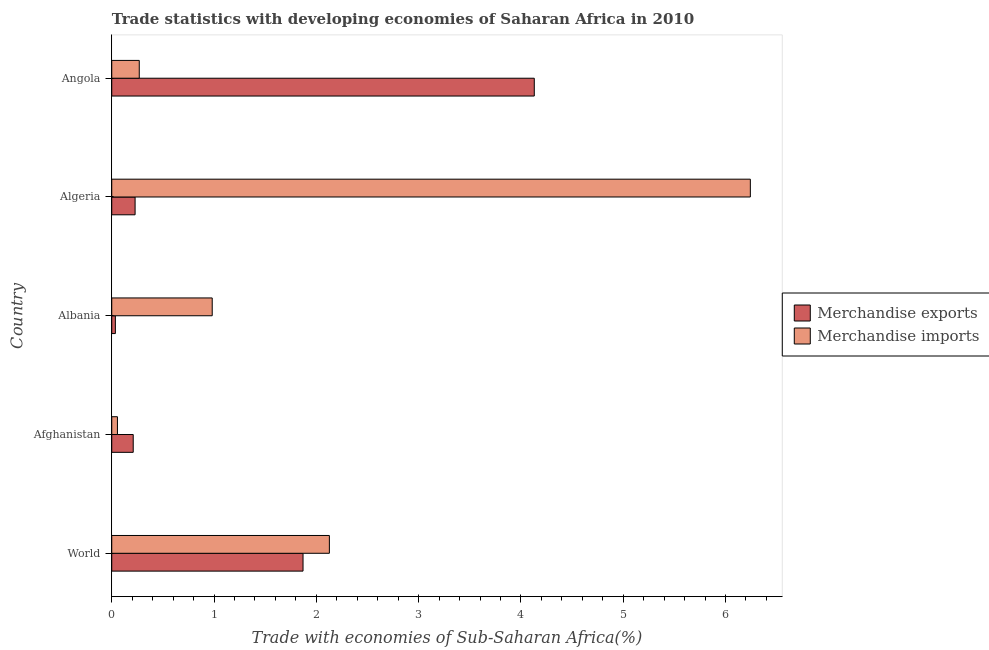How many different coloured bars are there?
Your response must be concise. 2. How many groups of bars are there?
Offer a very short reply. 5. Are the number of bars per tick equal to the number of legend labels?
Ensure brevity in your answer.  Yes. How many bars are there on the 1st tick from the bottom?
Your answer should be very brief. 2. What is the label of the 2nd group of bars from the top?
Make the answer very short. Algeria. In how many cases, is the number of bars for a given country not equal to the number of legend labels?
Your answer should be very brief. 0. What is the merchandise exports in Algeria?
Give a very brief answer. 0.23. Across all countries, what is the maximum merchandise imports?
Keep it short and to the point. 6.24. Across all countries, what is the minimum merchandise imports?
Give a very brief answer. 0.06. In which country was the merchandise exports maximum?
Your response must be concise. Angola. In which country was the merchandise exports minimum?
Give a very brief answer. Albania. What is the total merchandise imports in the graph?
Provide a succinct answer. 9.68. What is the difference between the merchandise imports in Afghanistan and that in Albania?
Provide a short and direct response. -0.93. What is the difference between the merchandise imports in World and the merchandise exports in Albania?
Keep it short and to the point. 2.09. What is the average merchandise exports per country?
Offer a very short reply. 1.29. What is the difference between the merchandise imports and merchandise exports in Albania?
Your response must be concise. 0.95. In how many countries, is the merchandise imports greater than 2.8 %?
Your response must be concise. 1. What is the ratio of the merchandise imports in Algeria to that in World?
Provide a succinct answer. 2.93. What is the difference between the highest and the second highest merchandise imports?
Keep it short and to the point. 4.12. Is the sum of the merchandise exports in Albania and Angola greater than the maximum merchandise imports across all countries?
Your answer should be very brief. No. What is the difference between two consecutive major ticks on the X-axis?
Make the answer very short. 1. Are the values on the major ticks of X-axis written in scientific E-notation?
Make the answer very short. No. Where does the legend appear in the graph?
Provide a succinct answer. Center right. How many legend labels are there?
Make the answer very short. 2. How are the legend labels stacked?
Your answer should be very brief. Vertical. What is the title of the graph?
Ensure brevity in your answer.  Trade statistics with developing economies of Saharan Africa in 2010. What is the label or title of the X-axis?
Your answer should be compact. Trade with economies of Sub-Saharan Africa(%). What is the Trade with economies of Sub-Saharan Africa(%) of Merchandise exports in World?
Your answer should be compact. 1.87. What is the Trade with economies of Sub-Saharan Africa(%) of Merchandise imports in World?
Ensure brevity in your answer.  2.13. What is the Trade with economies of Sub-Saharan Africa(%) in Merchandise exports in Afghanistan?
Give a very brief answer. 0.21. What is the Trade with economies of Sub-Saharan Africa(%) in Merchandise imports in Afghanistan?
Your answer should be very brief. 0.06. What is the Trade with economies of Sub-Saharan Africa(%) of Merchandise exports in Albania?
Offer a terse response. 0.04. What is the Trade with economies of Sub-Saharan Africa(%) of Merchandise imports in Albania?
Give a very brief answer. 0.98. What is the Trade with economies of Sub-Saharan Africa(%) in Merchandise exports in Algeria?
Provide a succinct answer. 0.23. What is the Trade with economies of Sub-Saharan Africa(%) of Merchandise imports in Algeria?
Your answer should be very brief. 6.24. What is the Trade with economies of Sub-Saharan Africa(%) in Merchandise exports in Angola?
Your response must be concise. 4.13. What is the Trade with economies of Sub-Saharan Africa(%) in Merchandise imports in Angola?
Ensure brevity in your answer.  0.27. Across all countries, what is the maximum Trade with economies of Sub-Saharan Africa(%) of Merchandise exports?
Provide a succinct answer. 4.13. Across all countries, what is the maximum Trade with economies of Sub-Saharan Africa(%) of Merchandise imports?
Your answer should be compact. 6.24. Across all countries, what is the minimum Trade with economies of Sub-Saharan Africa(%) in Merchandise exports?
Make the answer very short. 0.04. Across all countries, what is the minimum Trade with economies of Sub-Saharan Africa(%) in Merchandise imports?
Offer a very short reply. 0.06. What is the total Trade with economies of Sub-Saharan Africa(%) of Merchandise exports in the graph?
Your answer should be compact. 6.47. What is the total Trade with economies of Sub-Saharan Africa(%) of Merchandise imports in the graph?
Ensure brevity in your answer.  9.68. What is the difference between the Trade with economies of Sub-Saharan Africa(%) in Merchandise exports in World and that in Afghanistan?
Ensure brevity in your answer.  1.66. What is the difference between the Trade with economies of Sub-Saharan Africa(%) in Merchandise imports in World and that in Afghanistan?
Make the answer very short. 2.07. What is the difference between the Trade with economies of Sub-Saharan Africa(%) in Merchandise exports in World and that in Albania?
Provide a succinct answer. 1.83. What is the difference between the Trade with economies of Sub-Saharan Africa(%) of Merchandise imports in World and that in Albania?
Offer a terse response. 1.15. What is the difference between the Trade with economies of Sub-Saharan Africa(%) of Merchandise exports in World and that in Algeria?
Ensure brevity in your answer.  1.64. What is the difference between the Trade with economies of Sub-Saharan Africa(%) of Merchandise imports in World and that in Algeria?
Make the answer very short. -4.12. What is the difference between the Trade with economies of Sub-Saharan Africa(%) of Merchandise exports in World and that in Angola?
Make the answer very short. -2.26. What is the difference between the Trade with economies of Sub-Saharan Africa(%) in Merchandise imports in World and that in Angola?
Your answer should be compact. 1.86. What is the difference between the Trade with economies of Sub-Saharan Africa(%) of Merchandise exports in Afghanistan and that in Albania?
Your answer should be compact. 0.17. What is the difference between the Trade with economies of Sub-Saharan Africa(%) of Merchandise imports in Afghanistan and that in Albania?
Keep it short and to the point. -0.93. What is the difference between the Trade with economies of Sub-Saharan Africa(%) in Merchandise exports in Afghanistan and that in Algeria?
Ensure brevity in your answer.  -0.02. What is the difference between the Trade with economies of Sub-Saharan Africa(%) in Merchandise imports in Afghanistan and that in Algeria?
Ensure brevity in your answer.  -6.19. What is the difference between the Trade with economies of Sub-Saharan Africa(%) of Merchandise exports in Afghanistan and that in Angola?
Your response must be concise. -3.92. What is the difference between the Trade with economies of Sub-Saharan Africa(%) in Merchandise imports in Afghanistan and that in Angola?
Your answer should be very brief. -0.21. What is the difference between the Trade with economies of Sub-Saharan Africa(%) in Merchandise exports in Albania and that in Algeria?
Provide a short and direct response. -0.19. What is the difference between the Trade with economies of Sub-Saharan Africa(%) in Merchandise imports in Albania and that in Algeria?
Ensure brevity in your answer.  -5.26. What is the difference between the Trade with economies of Sub-Saharan Africa(%) in Merchandise exports in Albania and that in Angola?
Offer a very short reply. -4.1. What is the difference between the Trade with economies of Sub-Saharan Africa(%) in Merchandise imports in Albania and that in Angola?
Provide a short and direct response. 0.71. What is the difference between the Trade with economies of Sub-Saharan Africa(%) in Merchandise exports in Algeria and that in Angola?
Make the answer very short. -3.9. What is the difference between the Trade with economies of Sub-Saharan Africa(%) in Merchandise imports in Algeria and that in Angola?
Your response must be concise. 5.97. What is the difference between the Trade with economies of Sub-Saharan Africa(%) of Merchandise exports in World and the Trade with economies of Sub-Saharan Africa(%) of Merchandise imports in Afghanistan?
Your answer should be very brief. 1.81. What is the difference between the Trade with economies of Sub-Saharan Africa(%) of Merchandise exports in World and the Trade with economies of Sub-Saharan Africa(%) of Merchandise imports in Albania?
Your answer should be very brief. 0.89. What is the difference between the Trade with economies of Sub-Saharan Africa(%) in Merchandise exports in World and the Trade with economies of Sub-Saharan Africa(%) in Merchandise imports in Algeria?
Your answer should be compact. -4.37. What is the difference between the Trade with economies of Sub-Saharan Africa(%) of Merchandise exports in World and the Trade with economies of Sub-Saharan Africa(%) of Merchandise imports in Angola?
Your answer should be compact. 1.6. What is the difference between the Trade with economies of Sub-Saharan Africa(%) in Merchandise exports in Afghanistan and the Trade with economies of Sub-Saharan Africa(%) in Merchandise imports in Albania?
Provide a succinct answer. -0.77. What is the difference between the Trade with economies of Sub-Saharan Africa(%) of Merchandise exports in Afghanistan and the Trade with economies of Sub-Saharan Africa(%) of Merchandise imports in Algeria?
Your answer should be compact. -6.03. What is the difference between the Trade with economies of Sub-Saharan Africa(%) of Merchandise exports in Afghanistan and the Trade with economies of Sub-Saharan Africa(%) of Merchandise imports in Angola?
Offer a very short reply. -0.06. What is the difference between the Trade with economies of Sub-Saharan Africa(%) in Merchandise exports in Albania and the Trade with economies of Sub-Saharan Africa(%) in Merchandise imports in Algeria?
Keep it short and to the point. -6.21. What is the difference between the Trade with economies of Sub-Saharan Africa(%) of Merchandise exports in Albania and the Trade with economies of Sub-Saharan Africa(%) of Merchandise imports in Angola?
Your response must be concise. -0.23. What is the difference between the Trade with economies of Sub-Saharan Africa(%) in Merchandise exports in Algeria and the Trade with economies of Sub-Saharan Africa(%) in Merchandise imports in Angola?
Provide a short and direct response. -0.04. What is the average Trade with economies of Sub-Saharan Africa(%) in Merchandise exports per country?
Provide a short and direct response. 1.29. What is the average Trade with economies of Sub-Saharan Africa(%) of Merchandise imports per country?
Your answer should be very brief. 1.94. What is the difference between the Trade with economies of Sub-Saharan Africa(%) of Merchandise exports and Trade with economies of Sub-Saharan Africa(%) of Merchandise imports in World?
Keep it short and to the point. -0.26. What is the difference between the Trade with economies of Sub-Saharan Africa(%) of Merchandise exports and Trade with economies of Sub-Saharan Africa(%) of Merchandise imports in Afghanistan?
Your answer should be very brief. 0.15. What is the difference between the Trade with economies of Sub-Saharan Africa(%) in Merchandise exports and Trade with economies of Sub-Saharan Africa(%) in Merchandise imports in Albania?
Make the answer very short. -0.95. What is the difference between the Trade with economies of Sub-Saharan Africa(%) of Merchandise exports and Trade with economies of Sub-Saharan Africa(%) of Merchandise imports in Algeria?
Keep it short and to the point. -6.01. What is the difference between the Trade with economies of Sub-Saharan Africa(%) in Merchandise exports and Trade with economies of Sub-Saharan Africa(%) in Merchandise imports in Angola?
Your answer should be very brief. 3.86. What is the ratio of the Trade with economies of Sub-Saharan Africa(%) in Merchandise exports in World to that in Afghanistan?
Give a very brief answer. 8.91. What is the ratio of the Trade with economies of Sub-Saharan Africa(%) in Merchandise imports in World to that in Afghanistan?
Your answer should be compact. 38.2. What is the ratio of the Trade with economies of Sub-Saharan Africa(%) of Merchandise exports in World to that in Albania?
Your response must be concise. 52.76. What is the ratio of the Trade with economies of Sub-Saharan Africa(%) in Merchandise imports in World to that in Albania?
Your answer should be very brief. 2.17. What is the ratio of the Trade with economies of Sub-Saharan Africa(%) of Merchandise exports in World to that in Algeria?
Your answer should be very brief. 8.19. What is the ratio of the Trade with economies of Sub-Saharan Africa(%) in Merchandise imports in World to that in Algeria?
Your answer should be very brief. 0.34. What is the ratio of the Trade with economies of Sub-Saharan Africa(%) of Merchandise exports in World to that in Angola?
Keep it short and to the point. 0.45. What is the ratio of the Trade with economies of Sub-Saharan Africa(%) of Merchandise imports in World to that in Angola?
Ensure brevity in your answer.  7.91. What is the ratio of the Trade with economies of Sub-Saharan Africa(%) of Merchandise exports in Afghanistan to that in Albania?
Provide a succinct answer. 5.92. What is the ratio of the Trade with economies of Sub-Saharan Africa(%) in Merchandise imports in Afghanistan to that in Albania?
Ensure brevity in your answer.  0.06. What is the ratio of the Trade with economies of Sub-Saharan Africa(%) in Merchandise exports in Afghanistan to that in Algeria?
Keep it short and to the point. 0.92. What is the ratio of the Trade with economies of Sub-Saharan Africa(%) in Merchandise imports in Afghanistan to that in Algeria?
Provide a succinct answer. 0.01. What is the ratio of the Trade with economies of Sub-Saharan Africa(%) in Merchandise exports in Afghanistan to that in Angola?
Provide a short and direct response. 0.05. What is the ratio of the Trade with economies of Sub-Saharan Africa(%) of Merchandise imports in Afghanistan to that in Angola?
Your answer should be compact. 0.21. What is the ratio of the Trade with economies of Sub-Saharan Africa(%) of Merchandise exports in Albania to that in Algeria?
Your response must be concise. 0.16. What is the ratio of the Trade with economies of Sub-Saharan Africa(%) in Merchandise imports in Albania to that in Algeria?
Your answer should be very brief. 0.16. What is the ratio of the Trade with economies of Sub-Saharan Africa(%) of Merchandise exports in Albania to that in Angola?
Provide a succinct answer. 0.01. What is the ratio of the Trade with economies of Sub-Saharan Africa(%) in Merchandise imports in Albania to that in Angola?
Provide a short and direct response. 3.65. What is the ratio of the Trade with economies of Sub-Saharan Africa(%) of Merchandise exports in Algeria to that in Angola?
Offer a very short reply. 0.06. What is the ratio of the Trade with economies of Sub-Saharan Africa(%) in Merchandise imports in Algeria to that in Angola?
Keep it short and to the point. 23.21. What is the difference between the highest and the second highest Trade with economies of Sub-Saharan Africa(%) of Merchandise exports?
Provide a short and direct response. 2.26. What is the difference between the highest and the second highest Trade with economies of Sub-Saharan Africa(%) of Merchandise imports?
Offer a terse response. 4.12. What is the difference between the highest and the lowest Trade with economies of Sub-Saharan Africa(%) of Merchandise exports?
Provide a short and direct response. 4.1. What is the difference between the highest and the lowest Trade with economies of Sub-Saharan Africa(%) in Merchandise imports?
Offer a very short reply. 6.19. 